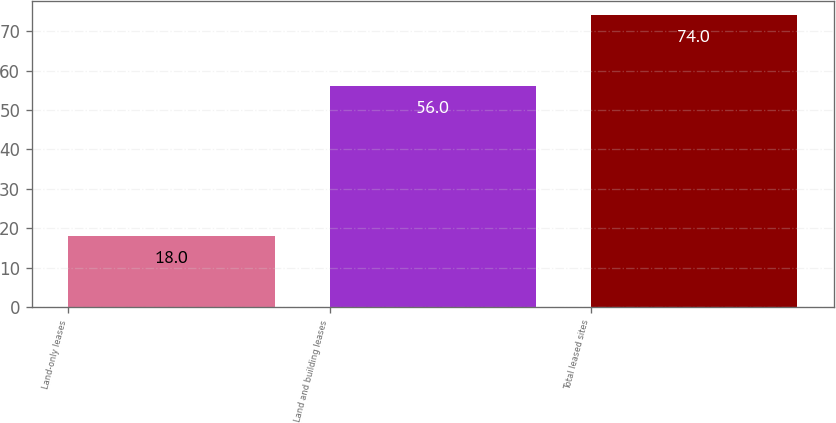Convert chart. <chart><loc_0><loc_0><loc_500><loc_500><bar_chart><fcel>Land-only leases<fcel>Land and building leases<fcel>Total leased sites<nl><fcel>18<fcel>56<fcel>74<nl></chart> 